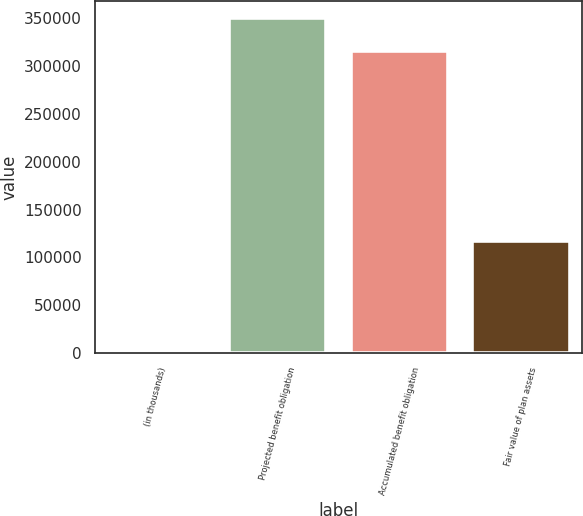Convert chart. <chart><loc_0><loc_0><loc_500><loc_500><bar_chart><fcel>(in thousands)<fcel>Projected benefit obligation<fcel>Accumulated benefit obligation<fcel>Fair value of plan assets<nl><fcel>2012<fcel>350227<fcel>315963<fcel>117413<nl></chart> 